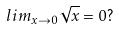Convert formula to latex. <formula><loc_0><loc_0><loc_500><loc_500>l i m _ { x \rightarrow 0 } \sqrt { x } = 0 ?</formula> 